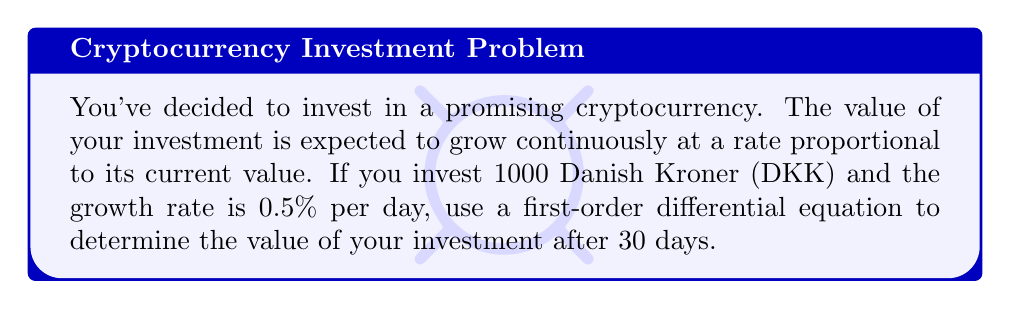Can you answer this question? Let's approach this step-by-step:

1) Let $V(t)$ be the value of the investment at time $t$ (in days).

2) The rate of change of the value is proportional to its current value. This can be expressed as:

   $$\frac{dV}{dt} = kV$$

   where $k$ is the growth rate constant.

3) We're given that the growth rate is 0.5% per day, so $k = 0.005$.

4) Our initial condition is $V(0) = 1000$ DKK.

5) The differential equation with initial condition is:

   $$\frac{dV}{dt} = 0.005V, \quad V(0) = 1000$$

6) This is a separable equation. Let's solve it:

   $$\frac{dV}{V} = 0.005dt$$

7) Integrating both sides:

   $$\int \frac{dV}{V} = \int 0.005dt$$
   $$\ln|V| = 0.005t + C$$

8) Applying the initial condition:

   $$\ln|1000| = 0 + C$$
   $$C = \ln|1000|$$

9) Therefore, the general solution is:

   $$\ln|V| = 0.005t + \ln|1000|$$
   $$V = 1000e^{0.005t}$$

10) To find the value after 30 days, we substitute $t = 30$:

    $$V(30) = 1000e^{0.005(30)}$$
    $$V(30) = 1000e^{0.15}$$
    $$V(30) = 1000(1.1618...)$$
    $$V(30) \approx 1161.83$$ DKK
Answer: The value of the investment after 30 days will be approximately 1161.83 DKK. 